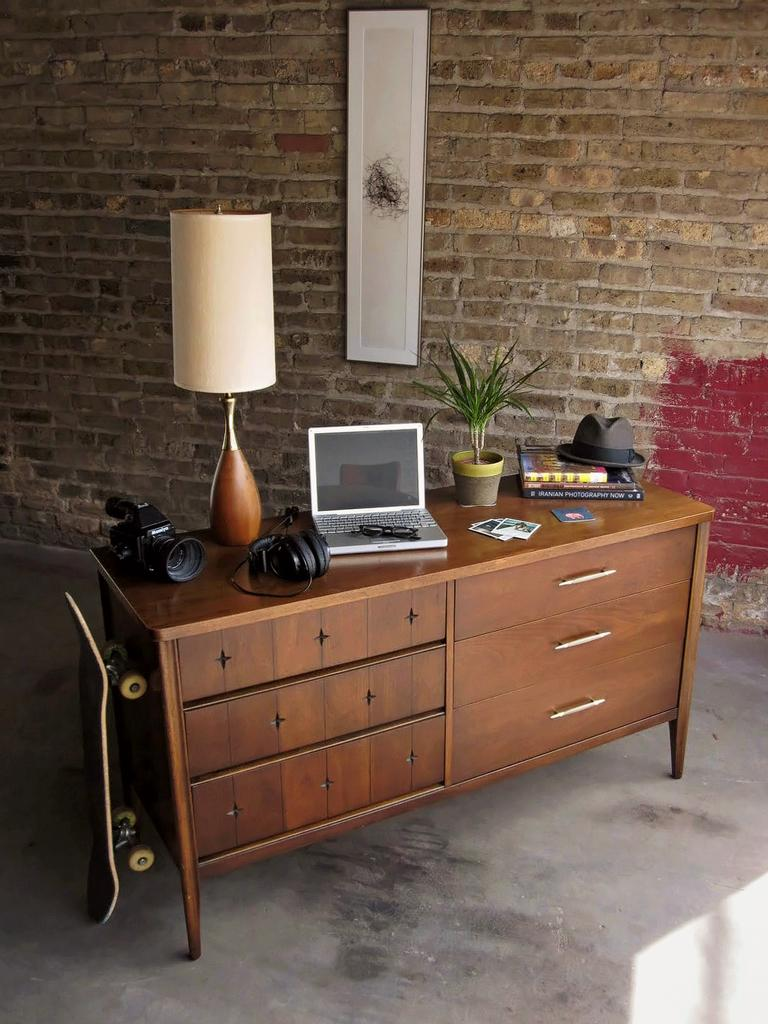What type of light source is visible in the image? There is a lamp in the image. What electronic device can be seen in the image? There is a laptop in the image. What device is used for capturing images in the image? There is a camera in the image. What type of container is present in the image? There is a small pot in the image. What type of clothing accessory is visible in the image? There is a cap in the image. What piece of furniture is present in the image? There is a table in the image. What is attached to the wall in the background of the image? There is a frame attached to a wall in the background of the image. What type of sponge is used for cleaning the laptop in the image? There is no sponge present in the image, nor is there any indication that the laptop is being cleaned. How does the camera blow air in the image? There is no indication that the camera is blowing air in the image; it is a device for capturing images. 